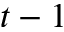<formula> <loc_0><loc_0><loc_500><loc_500>t - 1</formula> 